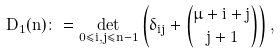Convert formula to latex. <formula><loc_0><loc_0><loc_500><loc_500>D _ { 1 } ( n ) \colon = \det _ { 0 \leq i , j \leq n - 1 } \left ( \delta _ { i j } + \binom { \mu + i + j } { j + 1 } \right ) ,</formula> 